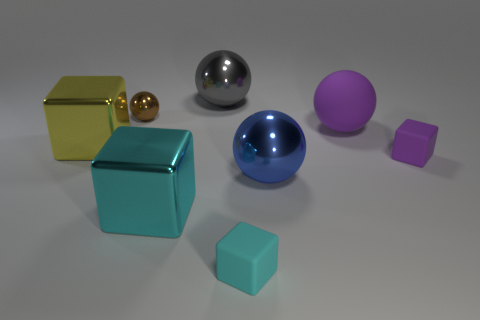There is a big rubber sphere; does it have the same color as the block right of the large purple object?
Keep it short and to the point. Yes. There is a rubber thing that is the same color as the matte sphere; what shape is it?
Provide a short and direct response. Cube. Is there a tiny block that has the same color as the matte sphere?
Offer a terse response. Yes. There is a sphere that is to the left of the cyan matte thing and right of the tiny metal sphere; what is its material?
Keep it short and to the point. Metal. There is a ball in front of the tiny purple matte cube; is there a tiny purple matte block that is behind it?
Offer a terse response. Yes. How many things are either blue metal cylinders or brown spheres?
Your answer should be compact. 1. There is a small object that is both in front of the matte sphere and to the left of the big purple rubber object; what shape is it?
Provide a short and direct response. Cube. Is the material of the large block to the right of the small brown metal ball the same as the big blue thing?
Your response must be concise. Yes. How many objects are either cyan metallic cubes or rubber things left of the purple matte cube?
Provide a succinct answer. 3. What is the color of the small ball that is made of the same material as the big blue thing?
Give a very brief answer. Brown. 